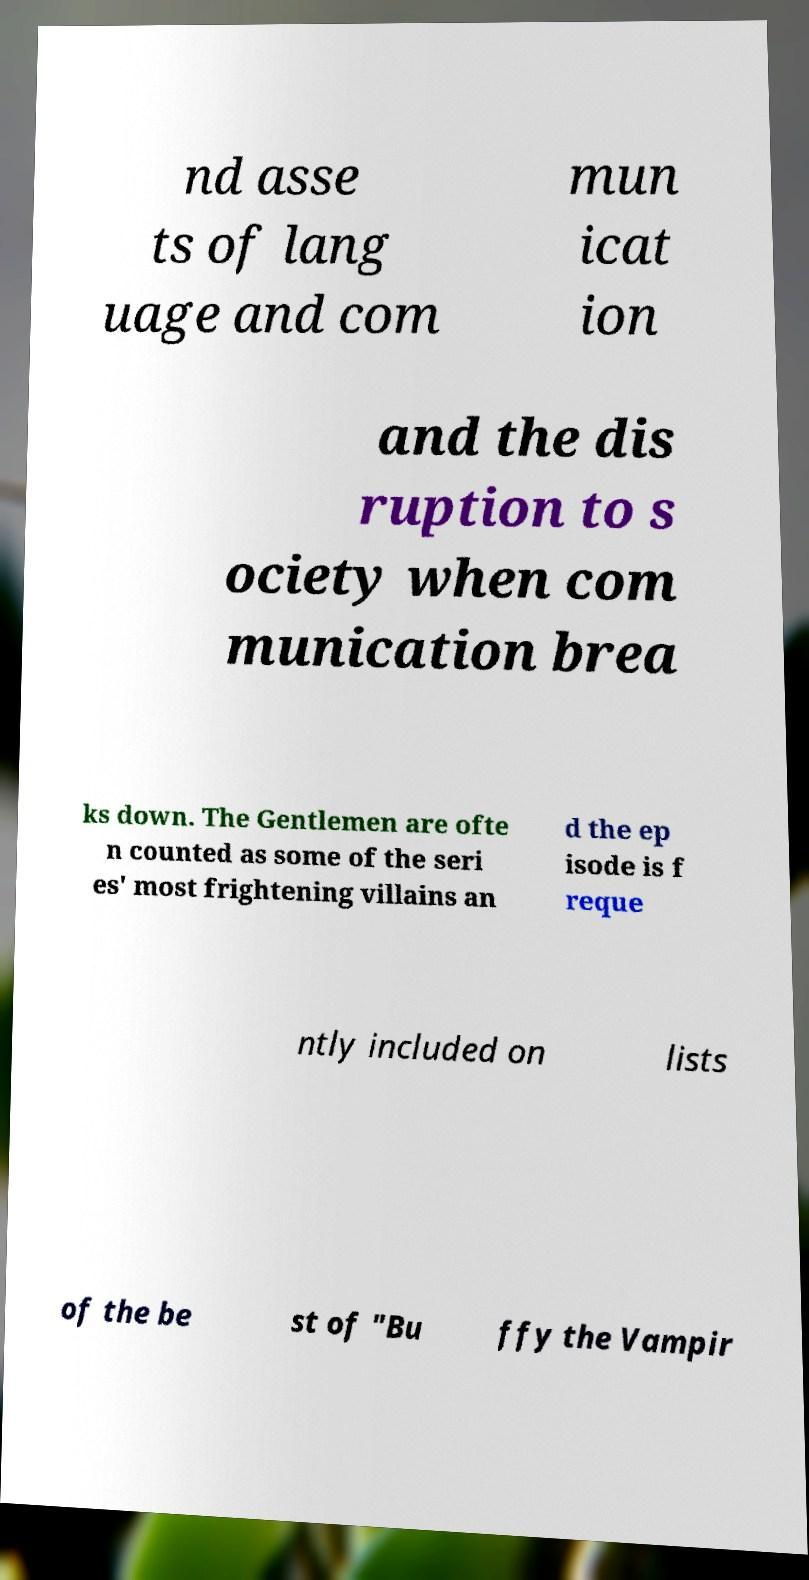Please read and relay the text visible in this image. What does it say? nd asse ts of lang uage and com mun icat ion and the dis ruption to s ociety when com munication brea ks down. The Gentlemen are ofte n counted as some of the seri es' most frightening villains an d the ep isode is f reque ntly included on lists of the be st of "Bu ffy the Vampir 